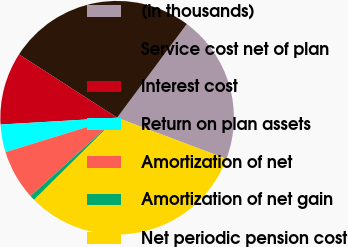Convert chart. <chart><loc_0><loc_0><loc_500><loc_500><pie_chart><fcel>(in thousands)<fcel>Service cost net of plan<fcel>Interest cost<fcel>Return on plan assets<fcel>Amortization of net<fcel>Amortization of net gain<fcel>Net periodic pension cost<nl><fcel>20.56%<fcel>26.06%<fcel>10.05%<fcel>3.83%<fcel>6.94%<fcel>0.72%<fcel>31.84%<nl></chart> 